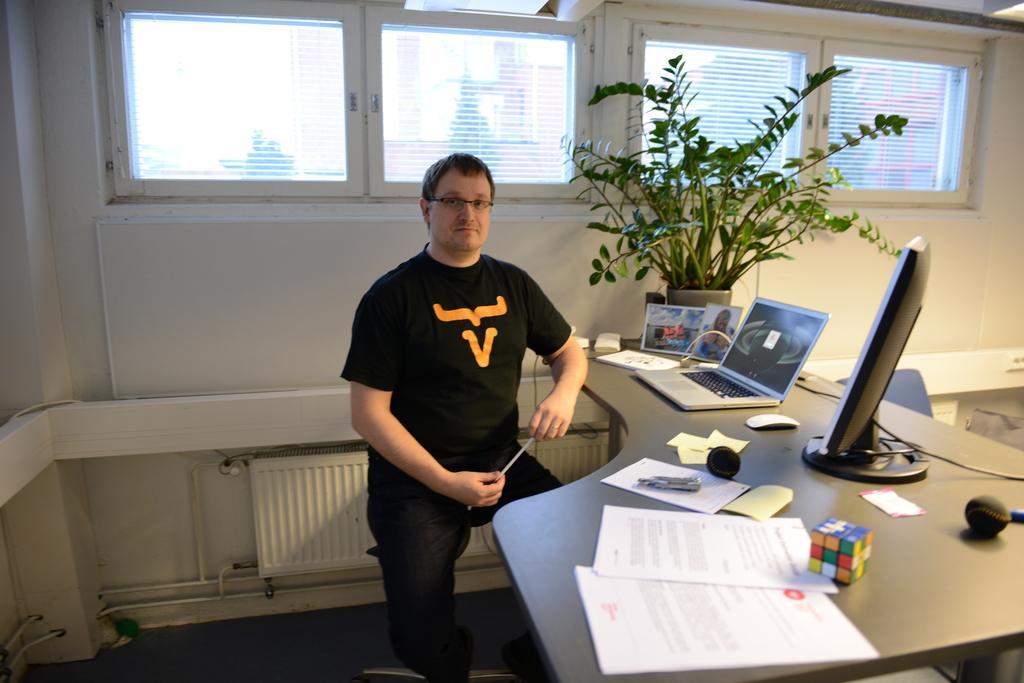Can you describe this image briefly? In the picture we can find a man with black T-shirt near the desk. On the desk we can find some papers, laptop, computer systems and plants, background we can find the windows with glass. 